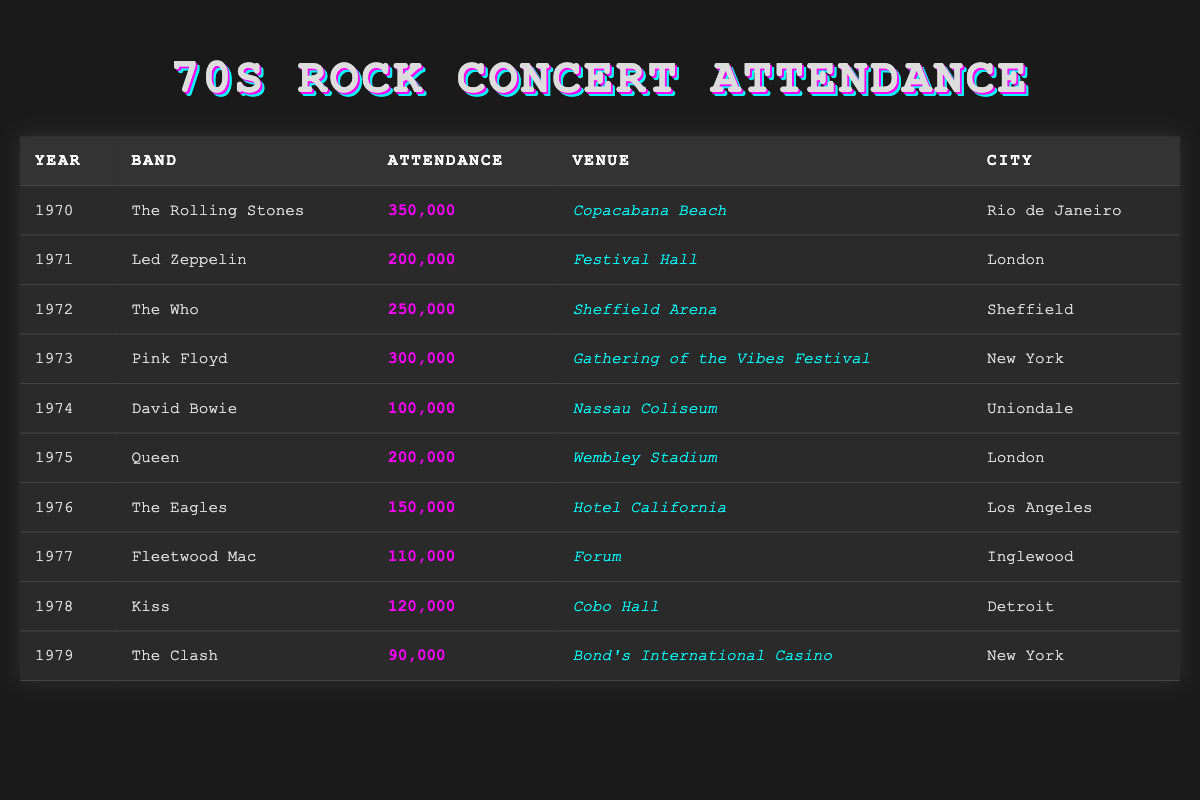What was the highest concert attendance in the 70s? The table shows concert attendance figures for various bands between 1970 and 1979. By scanning through the attendance figures, The Rolling Stones had the highest attendance at 350,000 in 1970.
Answer: 350,000 Which band performed in New York in 1973? The table lists concert data including year, band, venue, and city. By filtering the table for the year 1973, I see that Pink Floyd performed in New York.
Answer: Pink Floyd What is the average concert attendance for the years 1975 to 1979? First, I extract the attendance values from 1975 to 1979: 200,000 (Queen), 150,000 (The Eagles), 110,000 (Fleetwood Mac), 120,000 (Kiss), and 90,000 (The Clash). I then sum these values: 200,000 + 150,000 + 110,000 + 120,000 + 90,000 = 670,000. There are 5 years, so the average is 670,000 / 5 = 134,000.
Answer: 134,000 Did The Who have a higher attendance than Fleetwood Mac? The Who had an attendance of 250,000 in 1972, while Fleetwood Mac had an attendance of 110,000 in 1977. Since 250,000 is greater than 110,000, the answer is yes.
Answer: Yes In which city did David Bowie perform, and what was the attendance? According to the table, David Bowie performed in Uniondale, and the attendance was 100,000.
Answer: Uniondale, 100,000 What was the difference in attendance between the highest and lowest concerts in the table? The highest attendance was by The Rolling Stones at 350,000 and the lowest was by The Clash at 90,000. The difference is calculated by subtracting the lowest from the highest: 350,000 - 90,000 = 260,000.
Answer: 260,000 How many concerts had an attendance of over 200,000? I start by checking the attendance figures and count those over 200,000: The Rolling Stones (350,000), Led Zeppelin (200,000), The Who (250,000), and Pink Floyd (300,000), which totals 4 concerts that meet the criteria.
Answer: 4 Which venue had the highest attendance, and which band performed there? By reviewing the attendance figures, Copacabana Beach for The Rolling Stones had the highest attendance of 350,000. Hence, the answer is Vampire.
Answer: Copacabana Beach, The Rolling Stones 